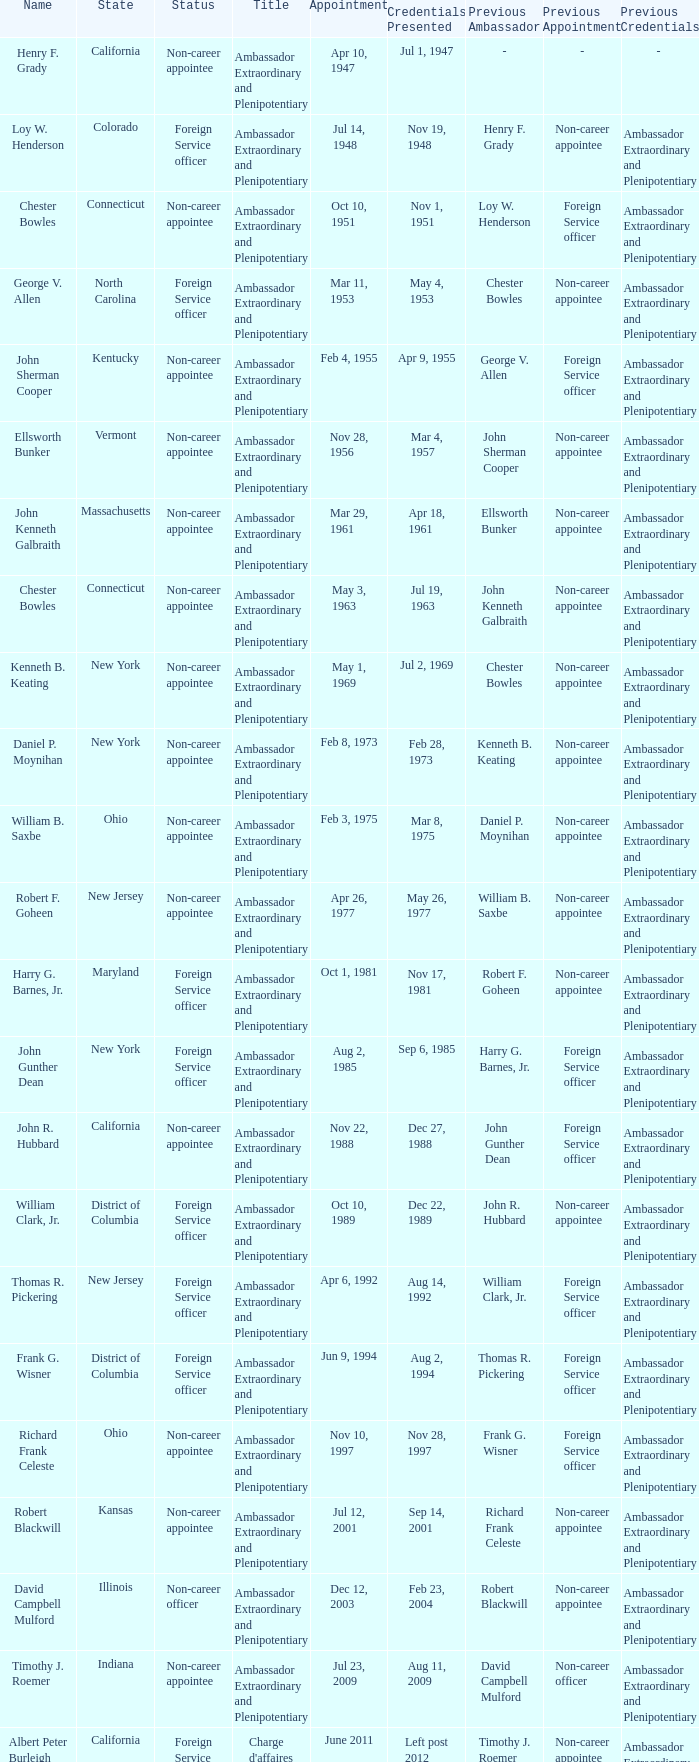What day were credentials presented for vermont? Mar 4, 1957. 